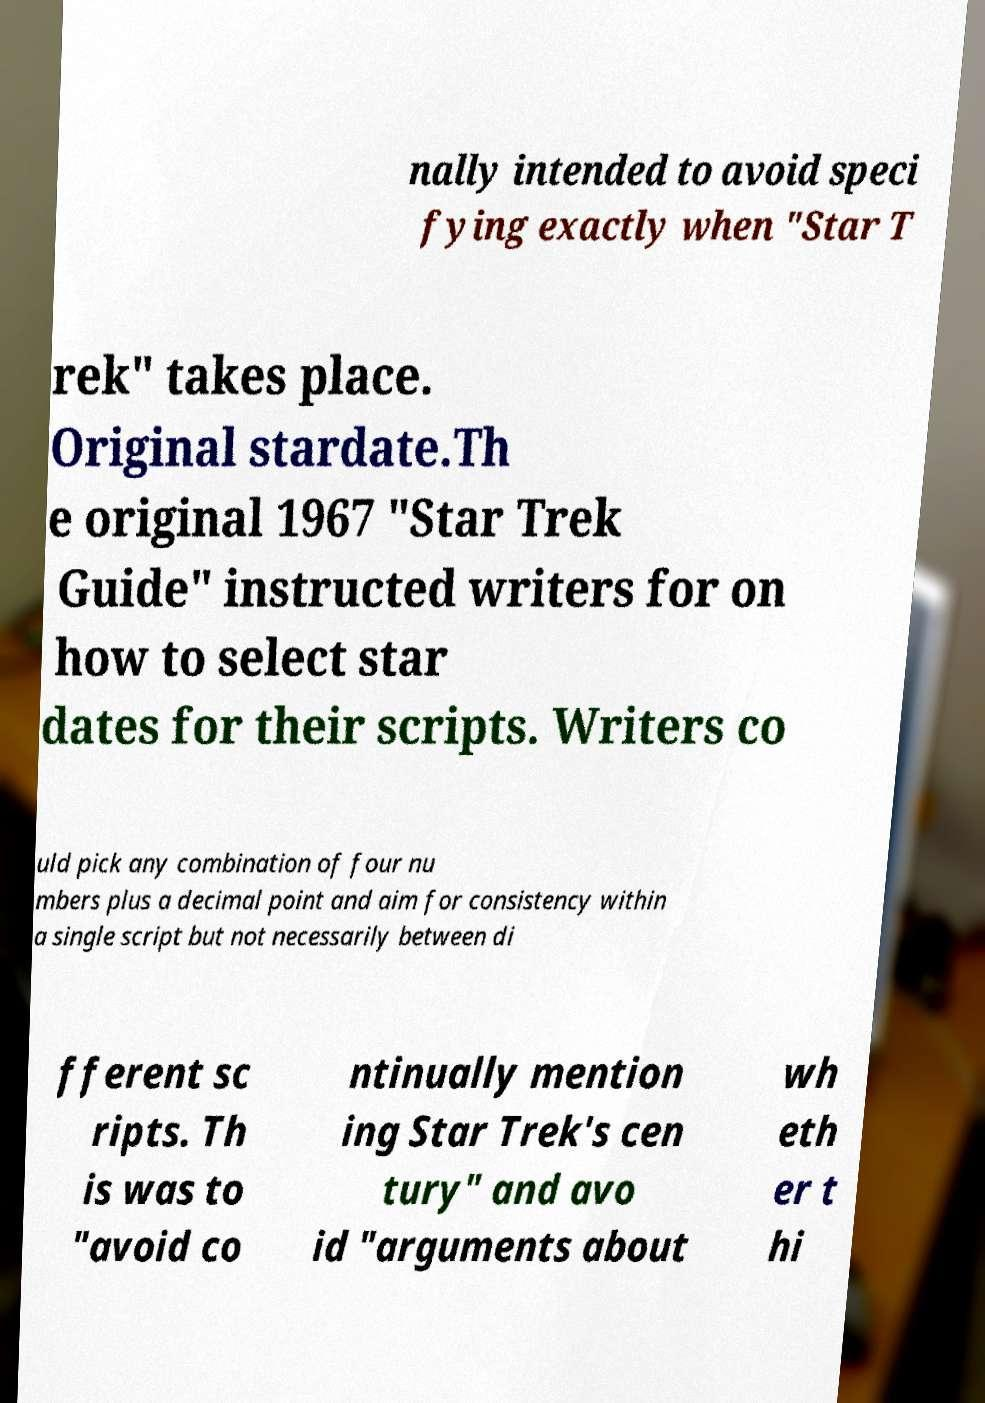What messages or text are displayed in this image? I need them in a readable, typed format. nally intended to avoid speci fying exactly when "Star T rek" takes place. Original stardate.Th e original 1967 "Star Trek Guide" instructed writers for on how to select star dates for their scripts. Writers co uld pick any combination of four nu mbers plus a decimal point and aim for consistency within a single script but not necessarily between di fferent sc ripts. Th is was to "avoid co ntinually mention ing Star Trek's cen tury" and avo id "arguments about wh eth er t hi 